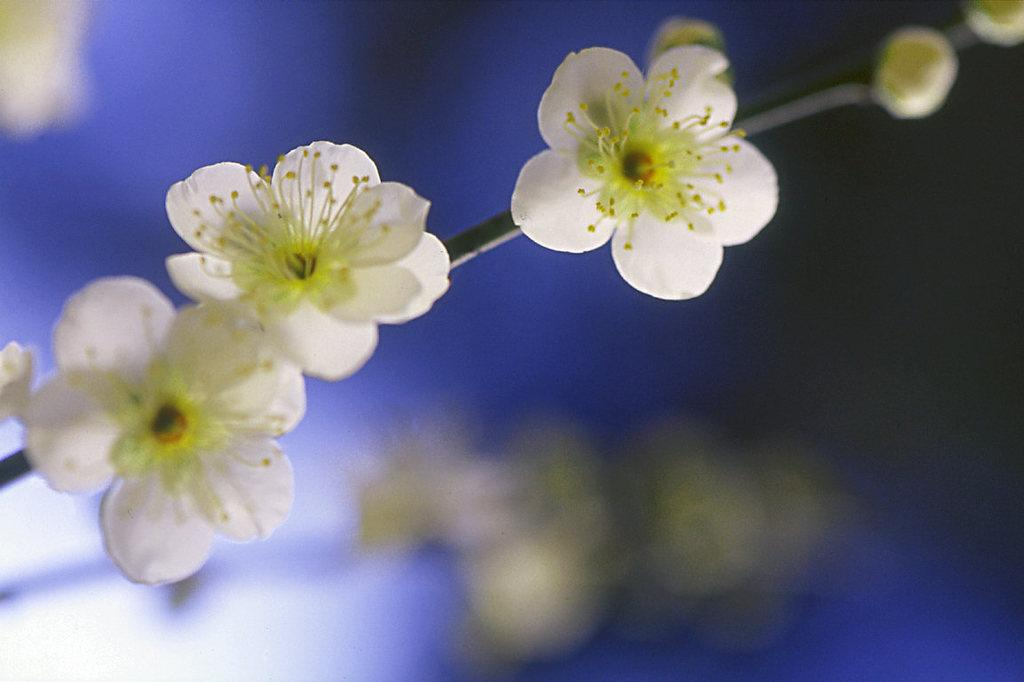What type of plants are visible in the image? There are flowering plants in the image. What color is the background of the image? The background color is blue. When was the image taken? The image was taken during nighttime. What type of tax is being discussed in the image? There is no discussion of tax in the image; it features flowering plants with a blue background taken during nighttime. 